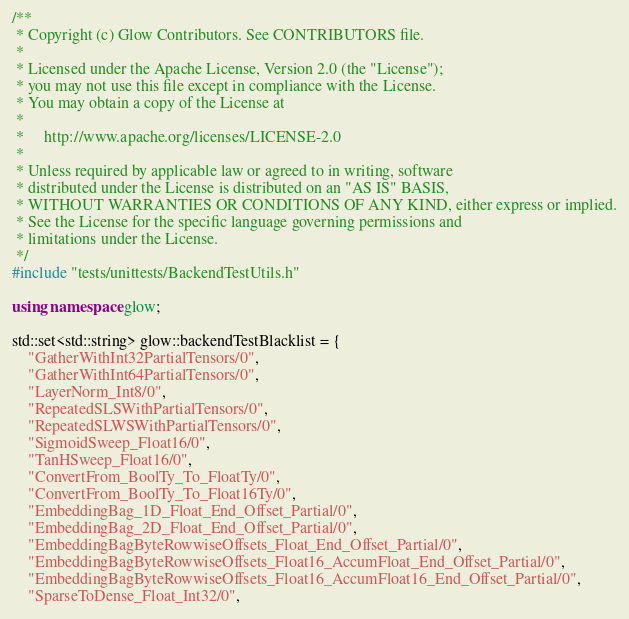<code> <loc_0><loc_0><loc_500><loc_500><_C++_>/**
 * Copyright (c) Glow Contributors. See CONTRIBUTORS file.
 *
 * Licensed under the Apache License, Version 2.0 (the "License");
 * you may not use this file except in compliance with the License.
 * You may obtain a copy of the License at
 *
 *     http://www.apache.org/licenses/LICENSE-2.0
 *
 * Unless required by applicable law or agreed to in writing, software
 * distributed under the License is distributed on an "AS IS" BASIS,
 * WITHOUT WARRANTIES OR CONDITIONS OF ANY KIND, either express or implied.
 * See the License for the specific language governing permissions and
 * limitations under the License.
 */
#include "tests/unittests/BackendTestUtils.h"

using namespace glow;

std::set<std::string> glow::backendTestBlacklist = {
    "GatherWithInt32PartialTensors/0",
    "GatherWithInt64PartialTensors/0",
    "LayerNorm_Int8/0",
    "RepeatedSLSWithPartialTensors/0",
    "RepeatedSLWSWithPartialTensors/0",
    "SigmoidSweep_Float16/0",
    "TanHSweep_Float16/0",
    "ConvertFrom_BoolTy_To_FloatTy/0",
    "ConvertFrom_BoolTy_To_Float16Ty/0",
    "EmbeddingBag_1D_Float_End_Offset_Partial/0",
    "EmbeddingBag_2D_Float_End_Offset_Partial/0",
    "EmbeddingBagByteRowwiseOffsets_Float_End_Offset_Partial/0",
    "EmbeddingBagByteRowwiseOffsets_Float16_AccumFloat_End_Offset_Partial/0",
    "EmbeddingBagByteRowwiseOffsets_Float16_AccumFloat16_End_Offset_Partial/0",
    "SparseToDense_Float_Int32/0",</code> 